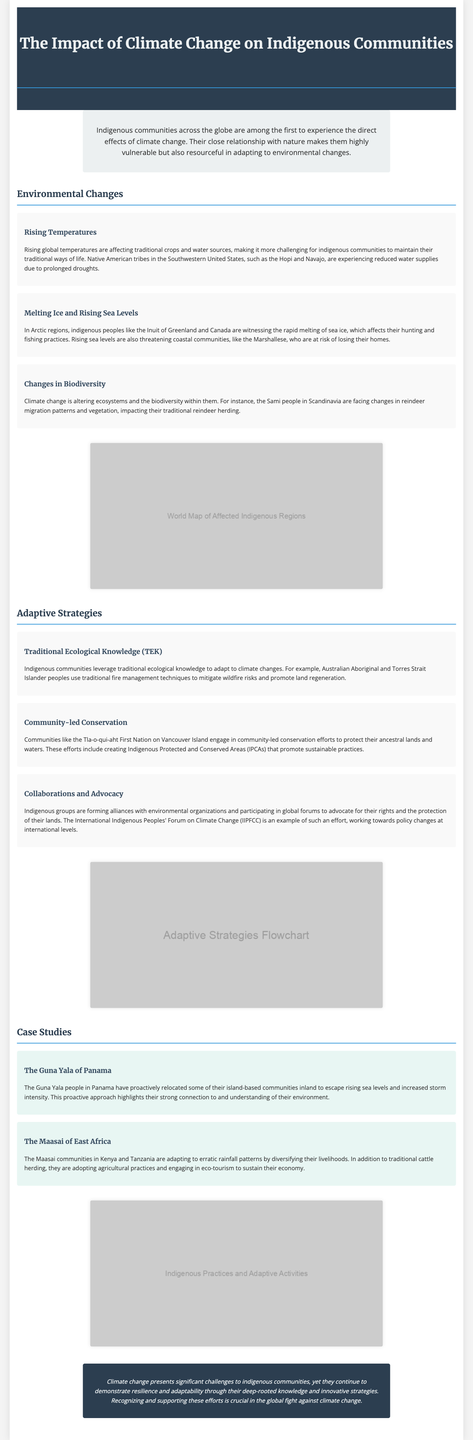what are the names of the Native American tribes affected by drought? The document mentions the Hopi and Navajo tribes that are experiencing reduced water supplies due to prolonged droughts.
Answer: Hopi and Navajo which indigenous peoples are mentioned as affected by melting ice? The Arctic regions' indigenous peoples include the Inuit of Greenland and Canada who are witnessing rapid melting of sea ice.
Answer: Inuit what adaptive strategy involves using traditional fire management techniques? The strategy that involves using traditional fire management techniques is attributed to Australian Aboriginal and Torres Strait Islander peoples for mitigating wildfire risks.
Answer: Traditional ecological knowledge what is a key example of community-led conservation mentioned in the document? The document highlights that the Tla-o-qui-aht First Nation engages in community-led conservation efforts by creating Indigenous Protected and Conserved Areas (IPCAs).
Answer: Indigenous Protected and Conserved Areas how are the Maasai adapting to erratic rainfall patterns? The Maasai communities in Kenya and Tanzania are diversifying their livelihoods by adopting agricultural practices and engaging in eco-tourism.
Answer: Diversifying livelihoods what does the conclusion emphasize regarding indigenous communities? The conclusion emphasizes the resilience and adaptability of indigenous communities through their deep-rooted knowledge and innovative strategies in the face of climate change.
Answer: Resilience and adaptability who are the Guna Yala people and what proactive measure did they take? The Guna Yala people are located in Panama and they have relocated some of their island-based communities inland to escape rising sea levels and storm intensity.
Answer: Relocated inland what type of document is this? It is a detailed infographic page focusing on the impact of climate change on indigenous communities and their adaptive strategies.
Answer: Infographic page 